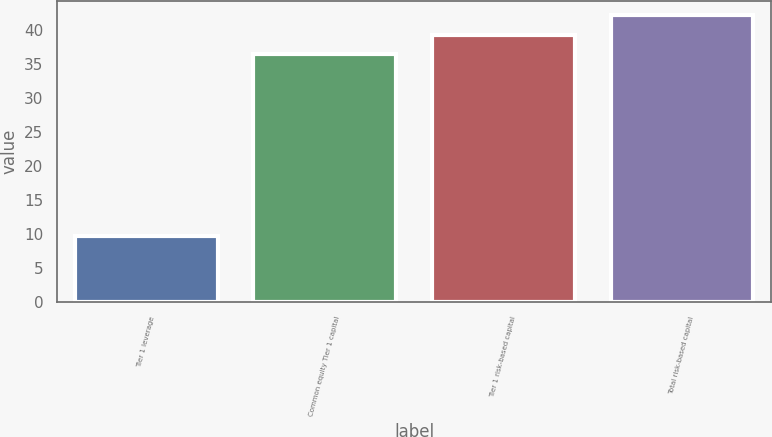Convert chart to OTSL. <chart><loc_0><loc_0><loc_500><loc_500><bar_chart><fcel>Tier 1 leverage<fcel>Common equity Tier 1 capital<fcel>Tier 1 risk-based capital<fcel>Total risk-based capital<nl><fcel>9.7<fcel>36.5<fcel>39.31<fcel>42.12<nl></chart> 